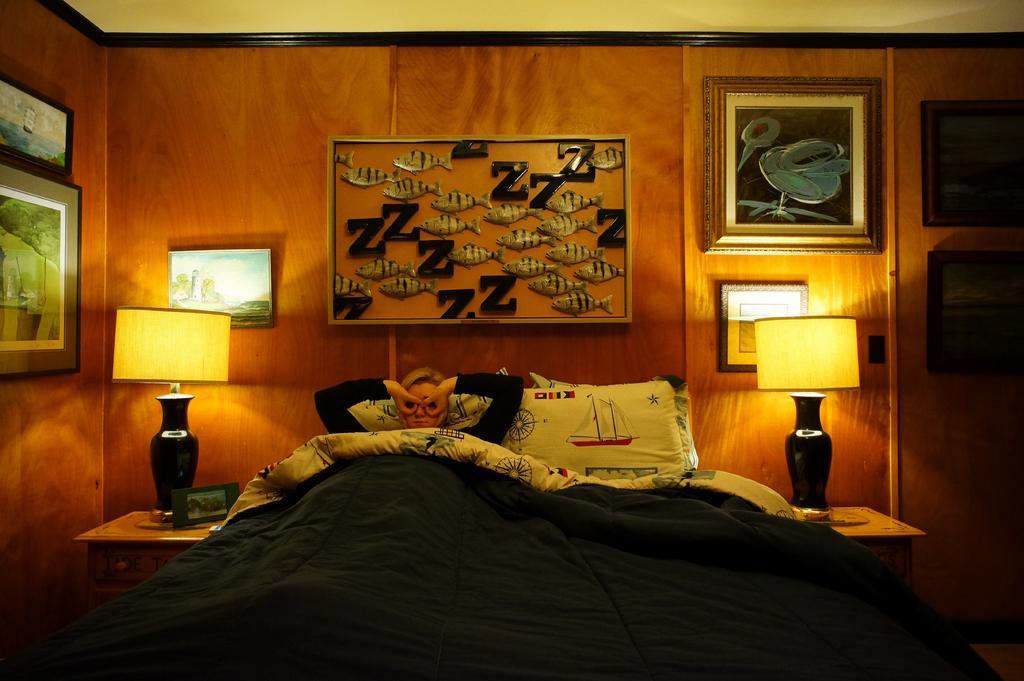Please provide a concise description of this image. There is a person on bed, we can see pillows and bed sheet. We can see lamps and frame on tables. In the background we can see frames on the wall. 